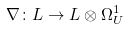Convert formula to latex. <formula><loc_0><loc_0><loc_500><loc_500>\nabla \colon L \to L \otimes \Omega ^ { 1 } _ { U }</formula> 